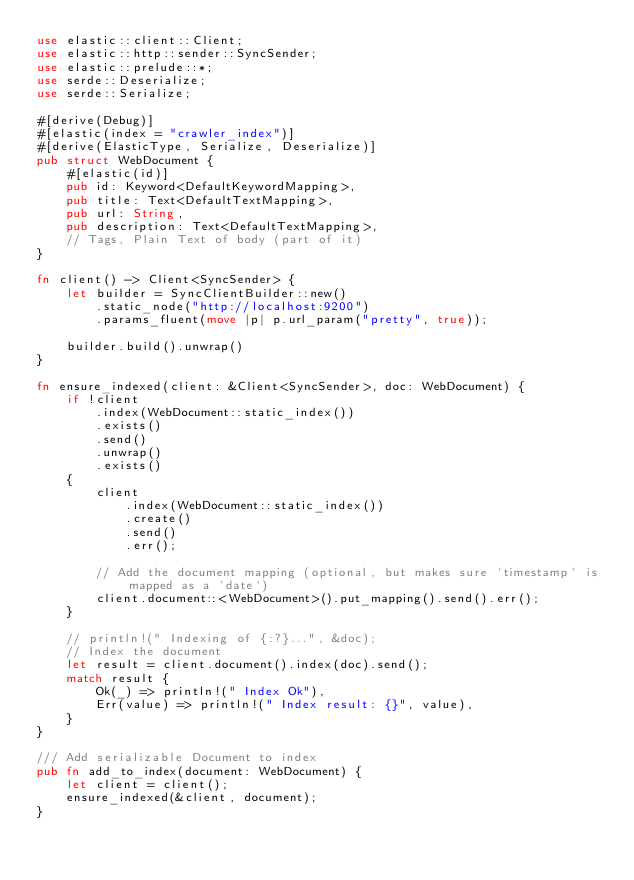Convert code to text. <code><loc_0><loc_0><loc_500><loc_500><_Rust_>use elastic::client::Client;
use elastic::http::sender::SyncSender;
use elastic::prelude::*;
use serde::Deserialize;
use serde::Serialize;

#[derive(Debug)]
#[elastic(index = "crawler_index")]
#[derive(ElasticType, Serialize, Deserialize)]
pub struct WebDocument {
    #[elastic(id)]
    pub id: Keyword<DefaultKeywordMapping>,
    pub title: Text<DefaultTextMapping>,
    pub url: String,
    pub description: Text<DefaultTextMapping>,
    // Tags, Plain Text of body (part of it)
}

fn client() -> Client<SyncSender> {
    let builder = SyncClientBuilder::new()
        .static_node("http://localhost:9200")
        .params_fluent(move |p| p.url_param("pretty", true));

    builder.build().unwrap()
}

fn ensure_indexed(client: &Client<SyncSender>, doc: WebDocument) {
    if !client
        .index(WebDocument::static_index())
        .exists()
        .send()
        .unwrap()
        .exists()
    {
        client
            .index(WebDocument::static_index())
            .create()
            .send()
            .err();

        // Add the document mapping (optional, but makes sure `timestamp` is mapped as a `date`)
        client.document::<WebDocument>().put_mapping().send().err();
    }

    // println!(" Indexing of {:?}...", &doc);
    // Index the document
    let result = client.document().index(doc).send();
    match result {
        Ok(_) => println!(" Index Ok"),
        Err(value) => println!(" Index result: {}", value),
    }
}

/// Add serializable Document to index
pub fn add_to_index(document: WebDocument) {
    let client = client();
    ensure_indexed(&client, document);
}
</code> 